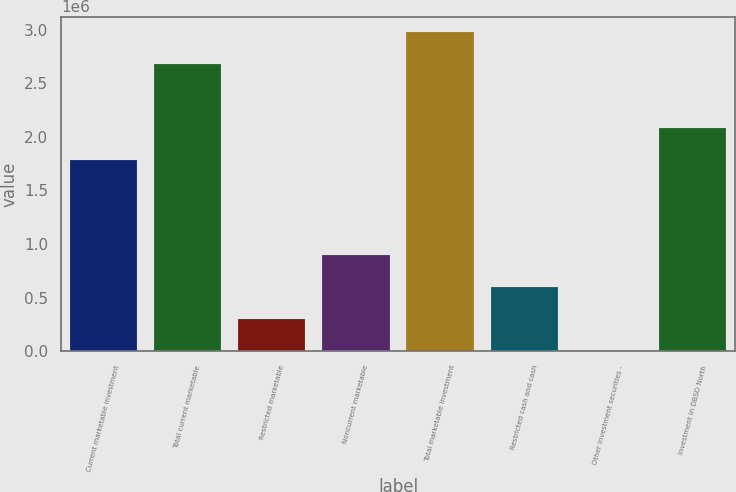Convert chart to OTSL. <chart><loc_0><loc_0><loc_500><loc_500><bar_chart><fcel>Current marketable investment<fcel>Total current marketable<fcel>Restricted marketable<fcel>Noncurrent marketable<fcel>Total marketable investment<fcel>Restricted cash and cash<fcel>Other investment securities -<fcel>Investment in DBSD North<nl><fcel>1.78548e+06<fcel>2.67681e+06<fcel>299917<fcel>894141<fcel>2.97393e+06<fcel>597029<fcel>2805<fcel>2.08259e+06<nl></chart> 